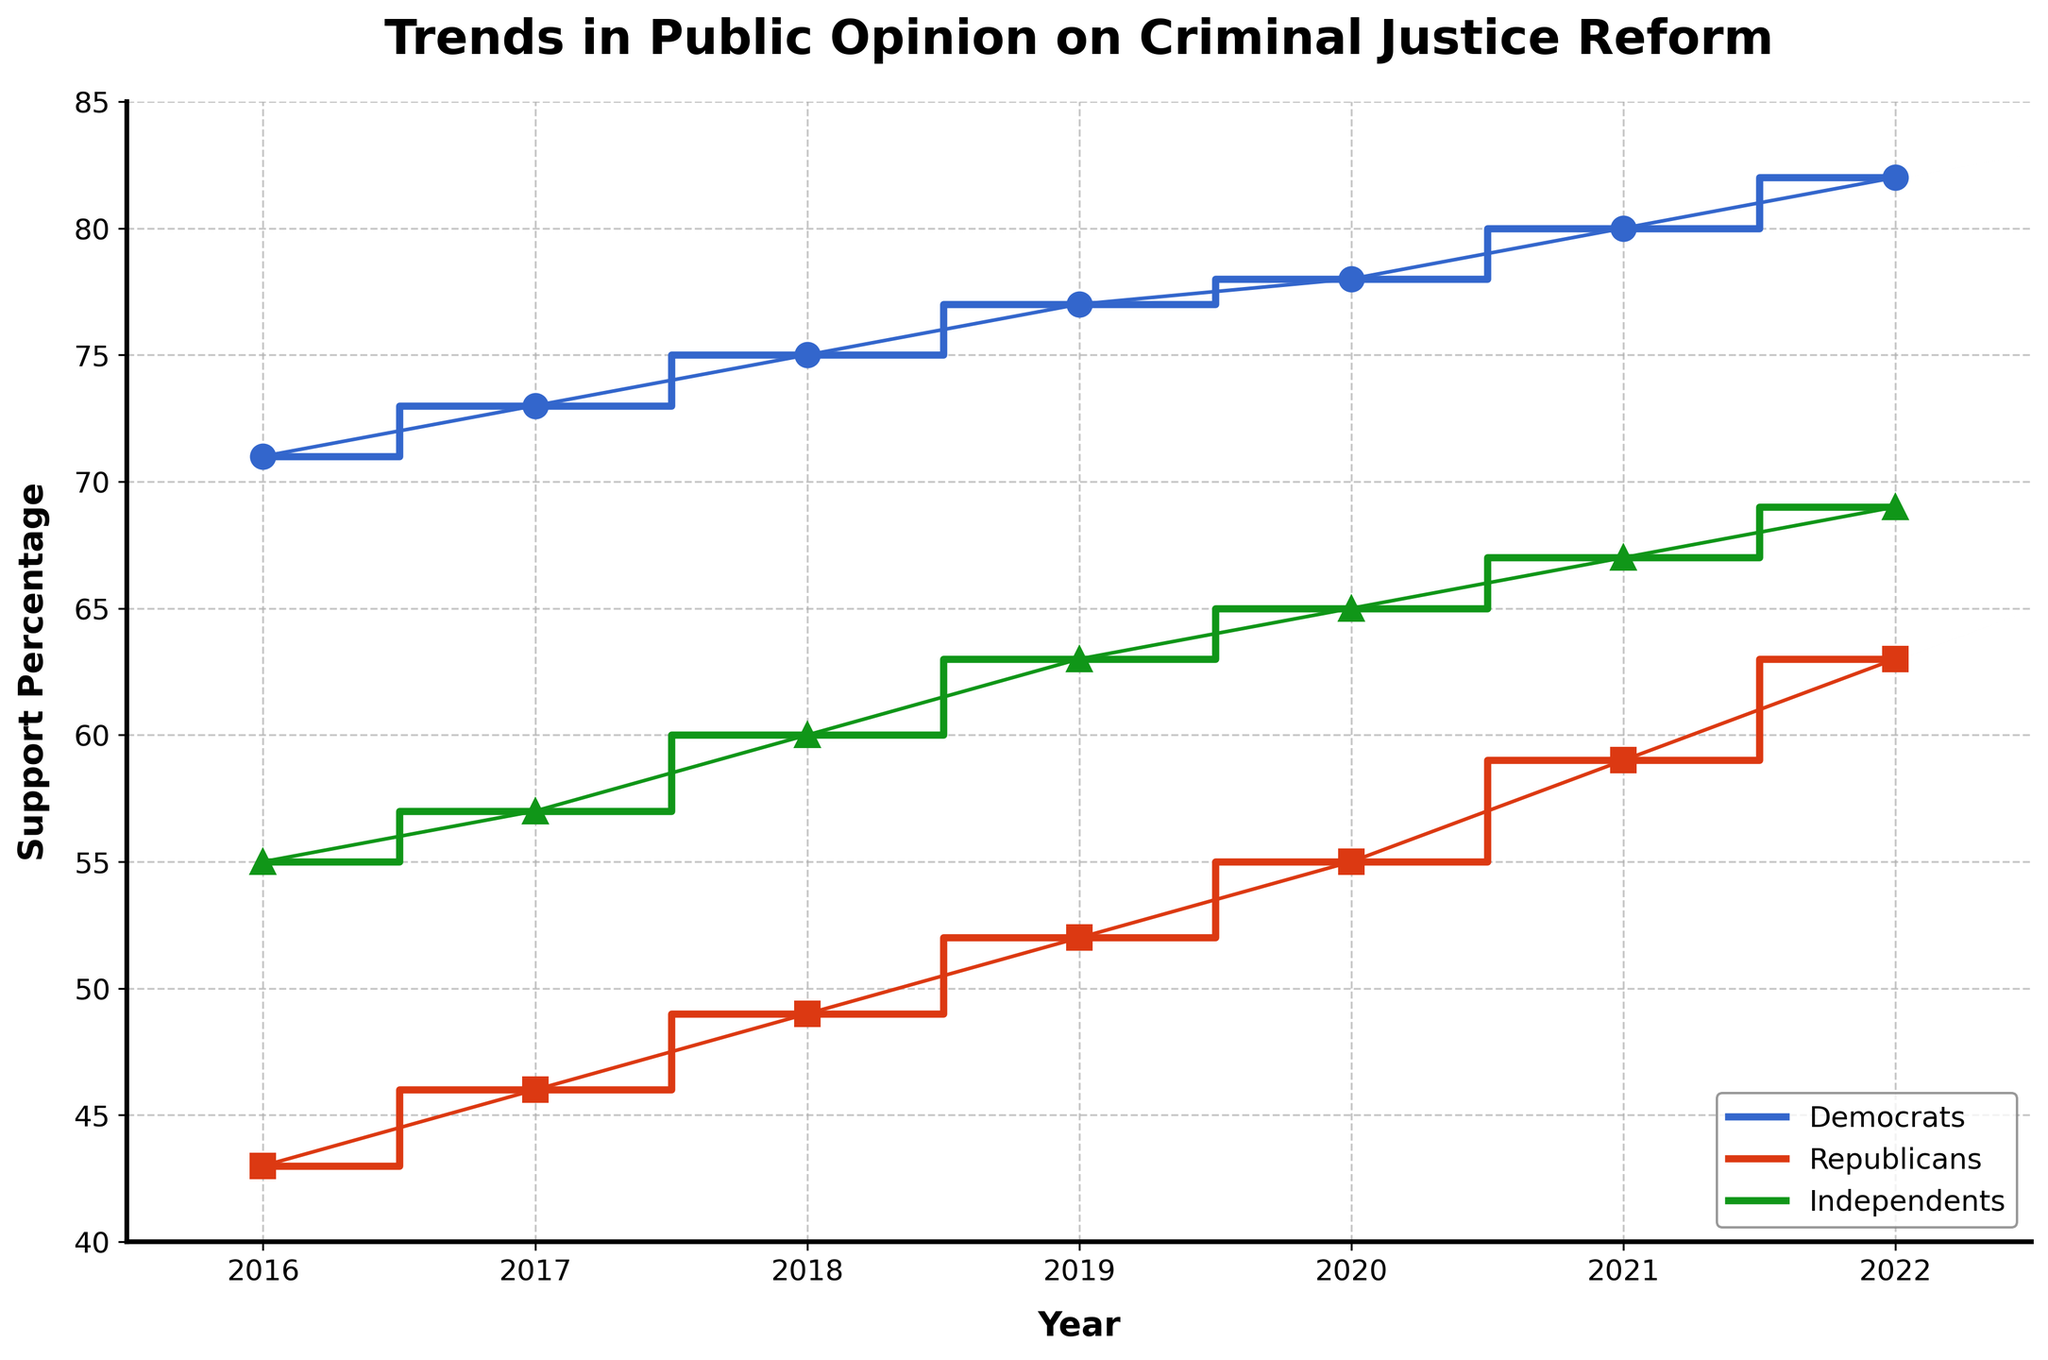- What is the title of the figure? The title is prominently displayed at the top of the figure.
Answer: Trends in Public Opinion on Criminal Justice Reform - What is the x-axis labeled as? The x-axis label is below the horizontal axis of the plot.
Answer: Year - What is the y-axis labeled as? The y-axis label is situated next to the vertical axis of the plot.
Answer: Support Percentage - Which political affiliation had the highest support percentage in 2022? Look at the 2022 data points and identify the affiliation with the highest value.
Answer: Democrats - How did the support percentage for Republicans change from 2016 to 2022? Observe the starting and ending points for the Republicans' data line. The support increased from 43% in 2016 to 63% in 2022.
Answer: Increased by 20% - What trend is observed in the support percentages for Independents over the years? Follow the data points for Independents from 2016 to 2022, noting the trend.
Answer: Consistently increased - In which year did Democrats surpass 75% support for the first time? Track the Democrats' data line and pinpoint the year when support first exceeds 75%.
Answer: 2018 - Which group showed the least amount of change in their support percentage from 2016 to 2022? Compare the changes in support percentages over the years for all three groups.
Answer: Independents - Which political affiliation shows the steepest increase in support percentage between 2017 and 2019? Compare the slope of the lines for each affiliation between 2017 and 2019. Democrats increased from 73% to 77%, Republicans from 46% to 52%, and Independents from 57% to 63%.
Answer: Republicans - What is the average support percentage for Independents from 2016 to 2022? Sum the support percentages for Independents from each year and divide by the number of years. (55 + 57 + 60 + 63 + 65 + 67 + 69)/7 = 62.29
Answer: 62.29 